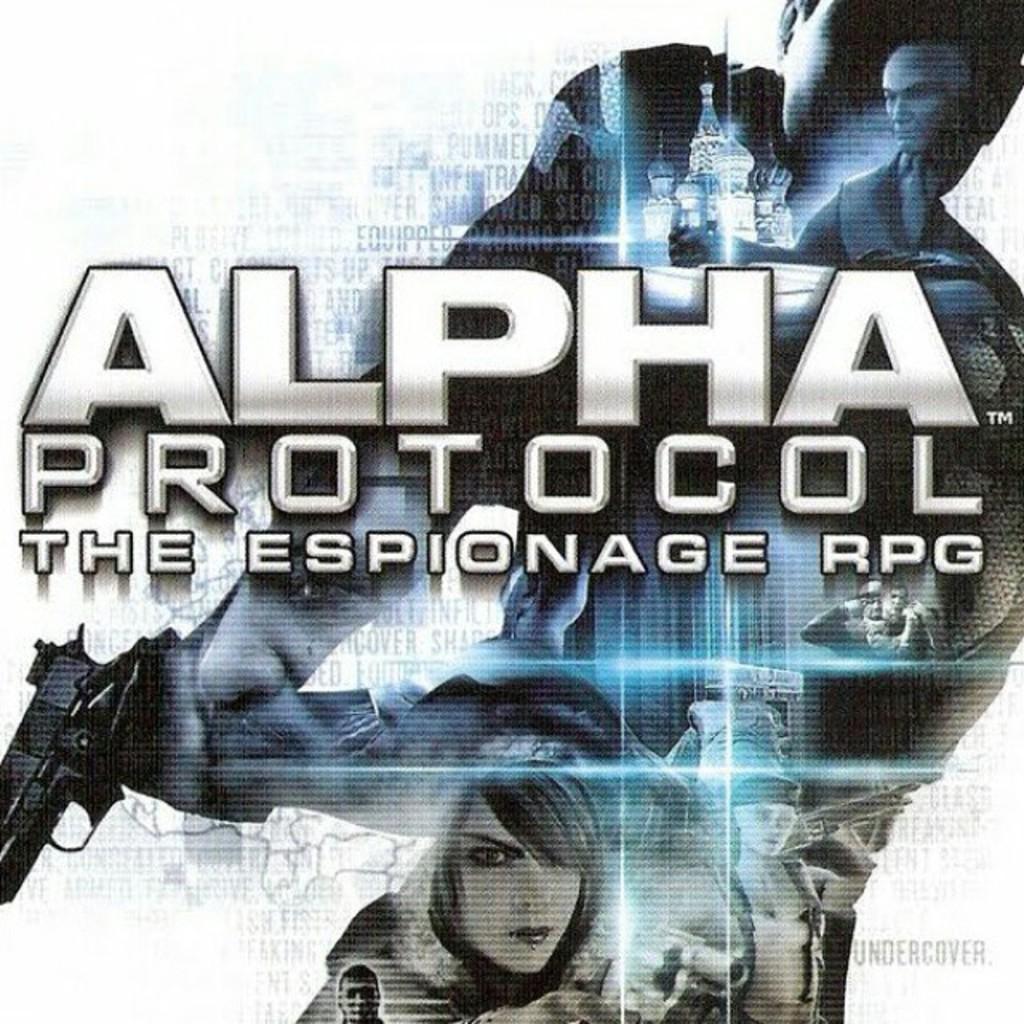In one or two sentences, can you explain what this image depicts? In this image we can see the poster with text and images. 